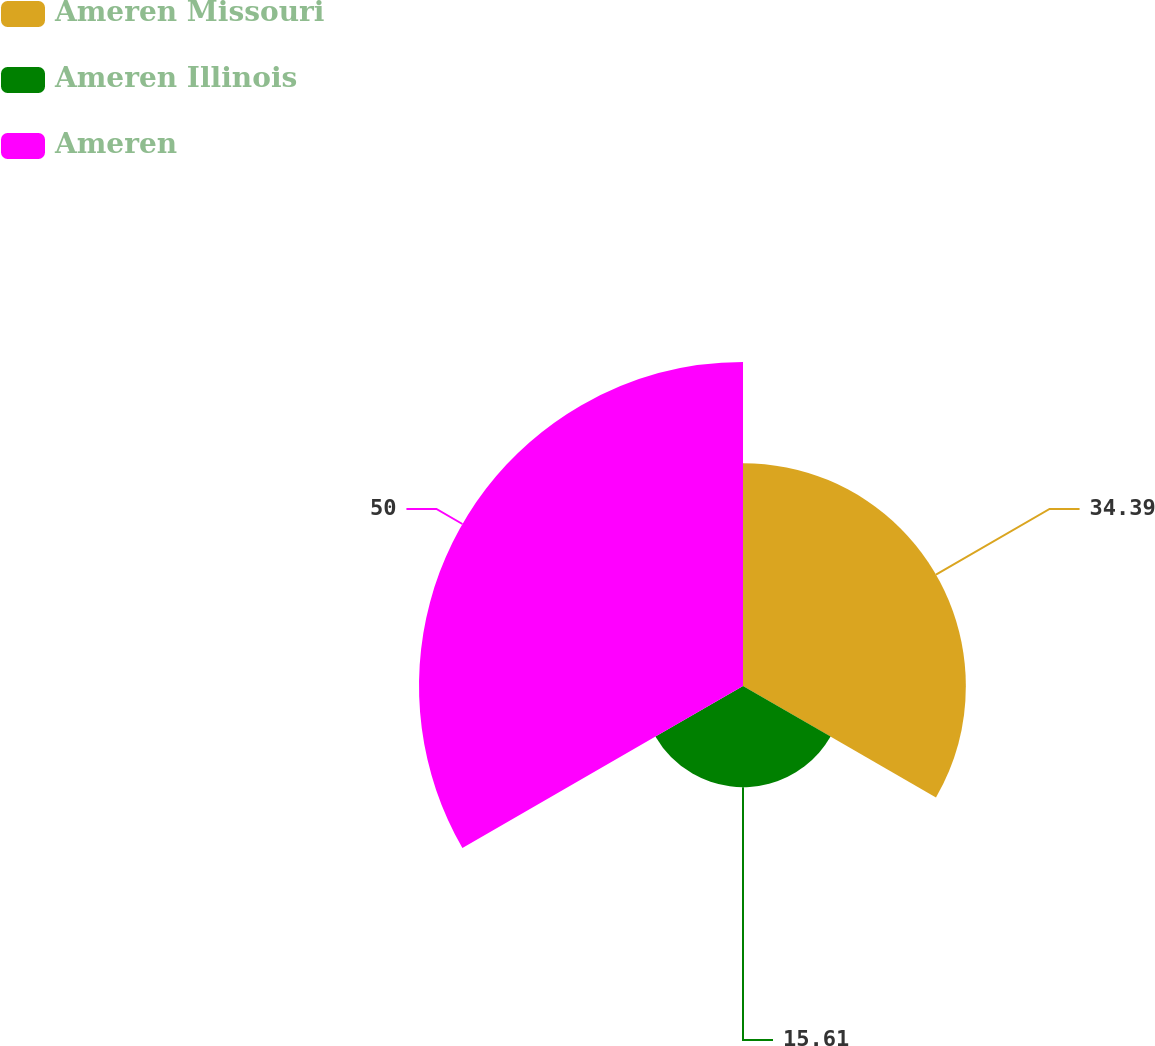<chart> <loc_0><loc_0><loc_500><loc_500><pie_chart><fcel>Ameren Missouri<fcel>Ameren Illinois<fcel>Ameren<nl><fcel>34.39%<fcel>15.61%<fcel>50.0%<nl></chart> 